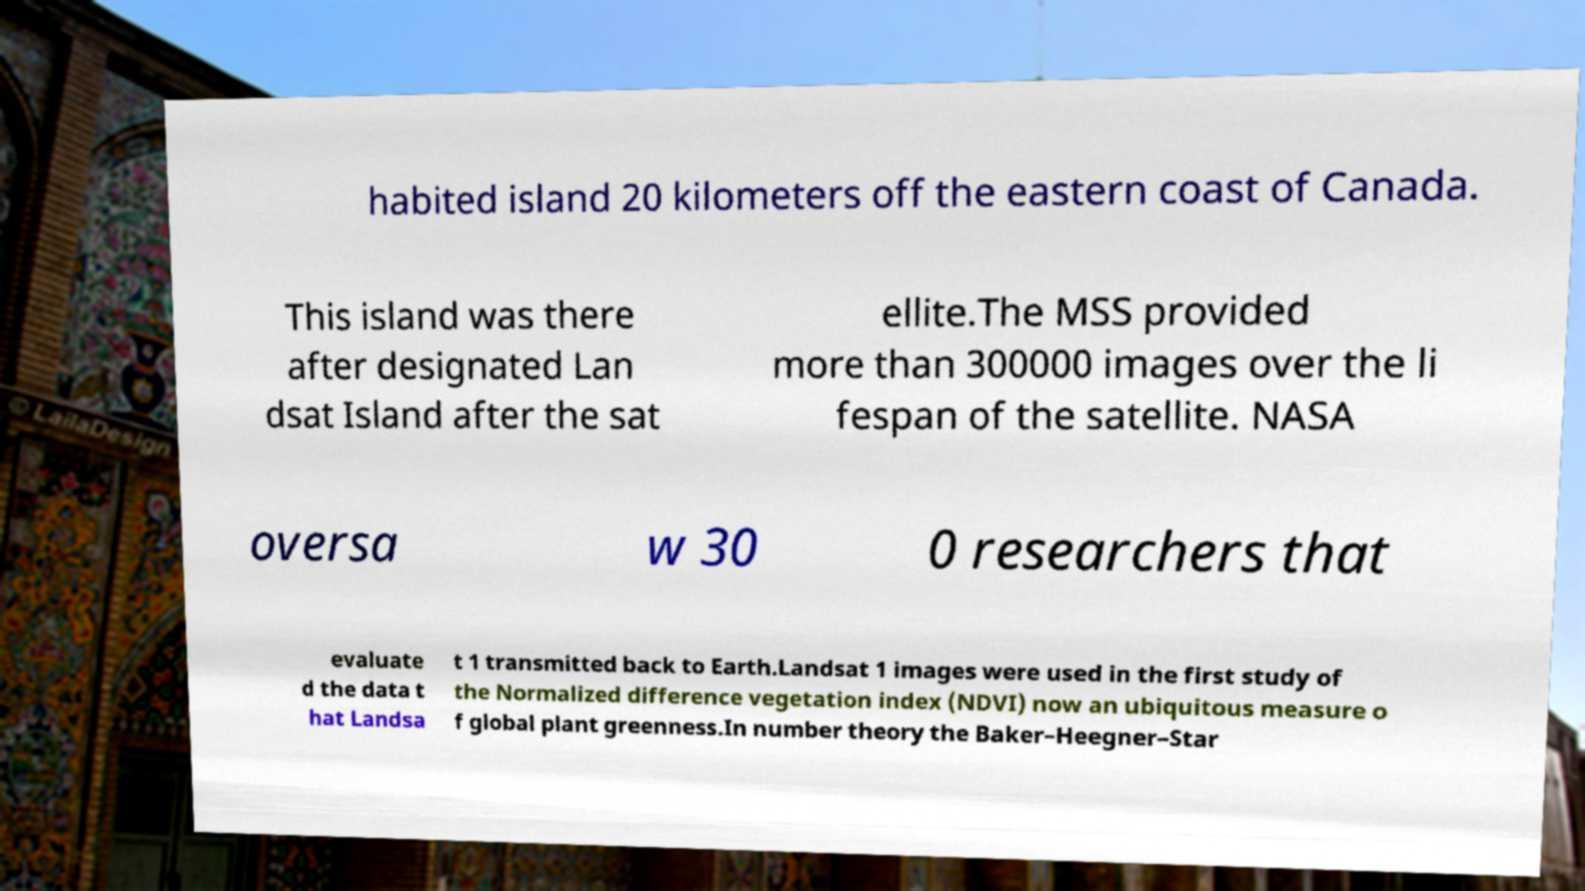Could you extract and type out the text from this image? habited island 20 kilometers off the eastern coast of Canada. This island was there after designated Lan dsat Island after the sat ellite.The MSS provided more than 300000 images over the li fespan of the satellite. NASA oversa w 30 0 researchers that evaluate d the data t hat Landsa t 1 transmitted back to Earth.Landsat 1 images were used in the first study of the Normalized difference vegetation index (NDVI) now an ubiquitous measure o f global plant greenness.In number theory the Baker–Heegner–Star 